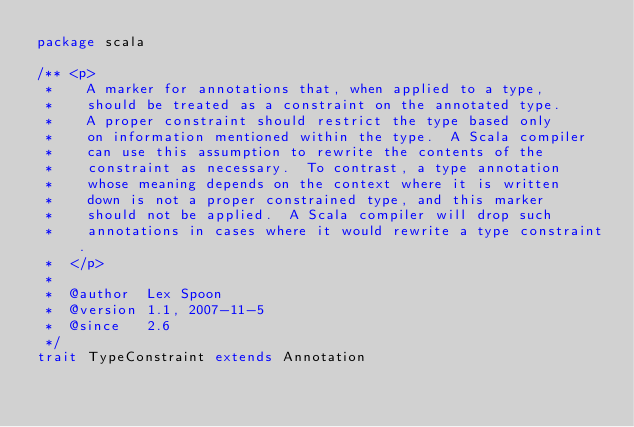Convert code to text. <code><loc_0><loc_0><loc_500><loc_500><_Scala_>package scala

/** <p>
 *    A marker for annotations that, when applied to a type,
 *    should be treated as a constraint on the annotated type.
 *    A proper constraint should restrict the type based only
 *    on information mentioned within the type.  A Scala compiler
 *    can use this assumption to rewrite the contents of the
 *    constraint as necessary.  To contrast, a type annotation
 *    whose meaning depends on the context where it is written
 *    down is not a proper constrained type, and this marker
 *    should not be applied.  A Scala compiler will drop such
 *    annotations in cases where it would rewrite a type constraint.
 *  </p>
 *
 *  @author  Lex Spoon
 *  @version 1.1, 2007-11-5
 *  @since   2.6
 */
trait TypeConstraint extends Annotation
</code> 